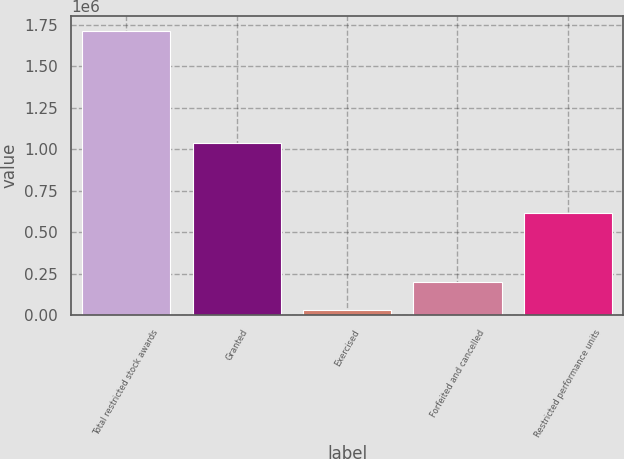<chart> <loc_0><loc_0><loc_500><loc_500><bar_chart><fcel>Total restricted stock awards<fcel>Granted<fcel>Exercised<fcel>Forfeited and cancelled<fcel>Restricted performance units<nl><fcel>1.71708e+06<fcel>1.03958e+06<fcel>30000<fcel>198708<fcel>617078<nl></chart> 